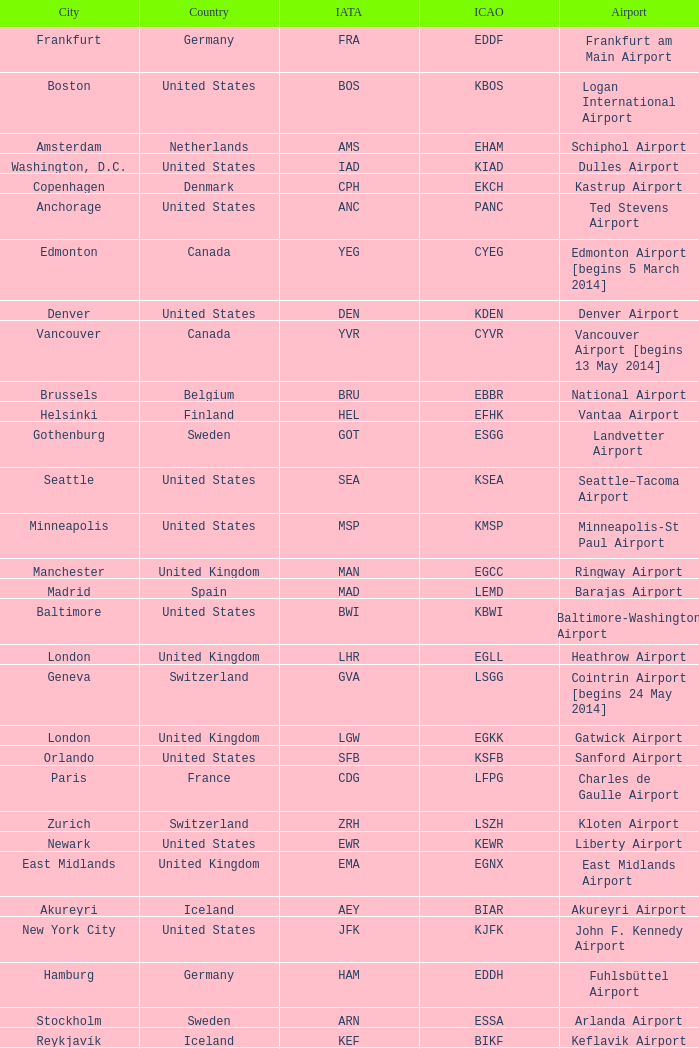What is the IATA OF Akureyri? AEY. 